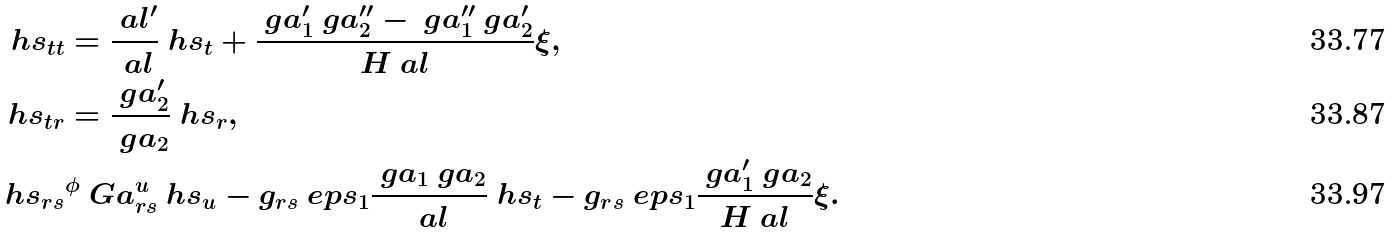<formula> <loc_0><loc_0><loc_500><loc_500>\ h s _ { t t } & = \frac { \ a l ^ { \prime } } { \ a l } \ h s _ { t } + \frac { \ g a _ { 1 } ^ { \prime } \ g a _ { 2 } ^ { \prime \prime } - \ g a _ { 1 } ^ { \prime \prime } \ g a _ { 2 } ^ { \prime } } { H \ a l } \xi , \\ \ h s _ { t r } & = \frac { \ g a _ { 2 } ^ { \prime } } { \ g a _ { 2 } } \ h s _ { r } , \\ \ h s _ { r s } & ^ { \phi } \ G a _ { r s } ^ { u } \ h s _ { u } - g _ { r s } \ e p s _ { 1 } \frac { \ g a _ { 1 } \ g a _ { 2 } } { \ a l } \ h s _ { t } - g _ { r s } \ e p s _ { 1 } \frac { \ g a _ { 1 } ^ { \prime } \ g a _ { 2 } } { H \ a l } \xi .</formula> 